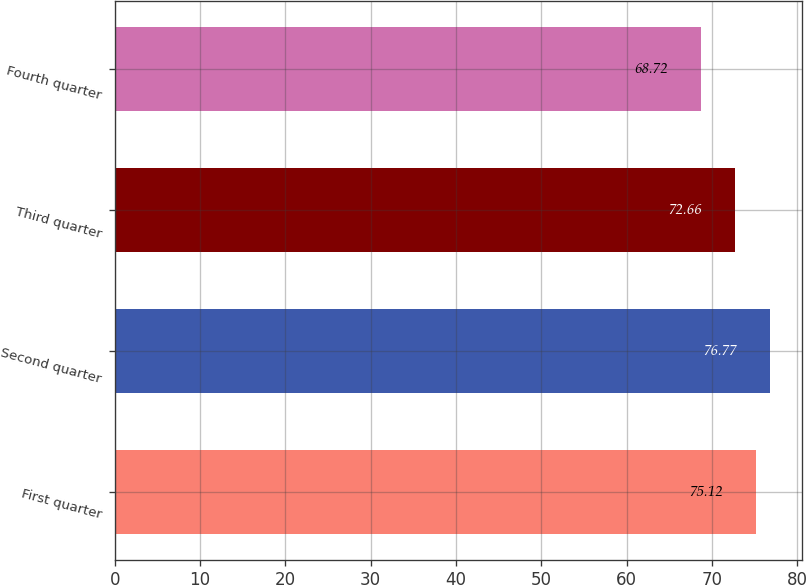<chart> <loc_0><loc_0><loc_500><loc_500><bar_chart><fcel>First quarter<fcel>Second quarter<fcel>Third quarter<fcel>Fourth quarter<nl><fcel>75.12<fcel>76.77<fcel>72.66<fcel>68.72<nl></chart> 